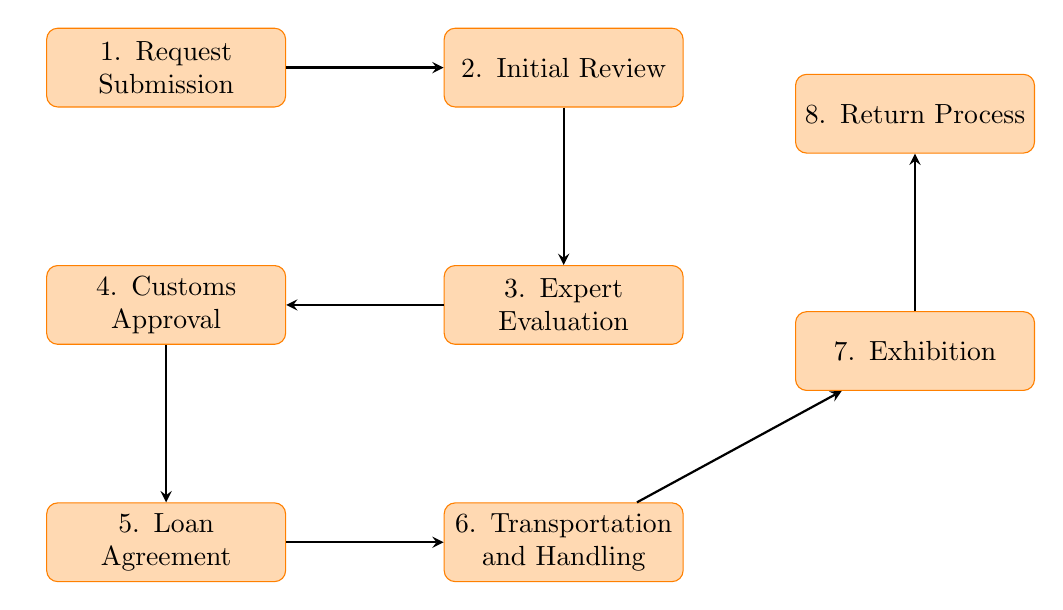What is the first step in the process? The diagram begins with the "Request Submission" node, which indicates that a cultural institution must first submit a formal loan request.
Answer: Request Submission How many nodes are present in the diagram? The diagram contains eight distinct nodes representing each step in the procedure for the temporary loan of cultural artifacts.
Answer: Eight What follows the "Expert Evaluation" step? After "Expert Evaluation," the next node is "Customs Approval," which indicates that customs reviews the evaluation before it proceeds further in the process.
Answer: Customs Approval Which node involves the legal signing process? The "Loan Agreement" node is where the legal loan agreement is signed between the cultural institution and the artifact's owner, indicating the official authorization of the loan.
Answer: Loan Agreement What is the last step before the artifact is returned? Before the artifact is returned, it goes through the "Exhibition" step, where it is displayed at the cultural institution while following security and preservation protocols.
Answer: Exhibition How does the process flow from "Customs Approval" to "Loan Agreement"? The flow continues directly from "Customs Approval" to "Loan Agreement," meaning once customs approves, the next step involves signing the loan agreement.
Answer: Loan Agreement What step ensures the safety of the artifact during transport? The "Transportation and Handling" step is specifically designed to ensure the safe transport and handling of the artifact, adhering to international guidelines.
Answer: Transportation and Handling Which step occurs after the artifact is exhibited? The "Return Process" immediately follows the "Exhibition" step, indicating that once the exhibition concludes, the artifact must be returned to its owner.
Answer: Return Process 